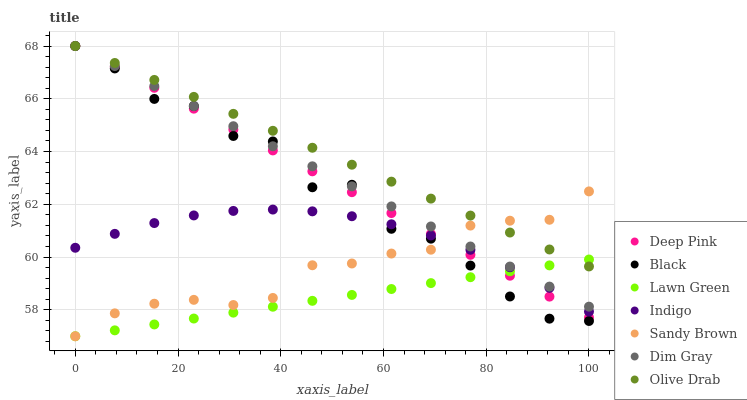Does Lawn Green have the minimum area under the curve?
Answer yes or no. Yes. Does Olive Drab have the maximum area under the curve?
Answer yes or no. Yes. Does Dim Gray have the minimum area under the curve?
Answer yes or no. No. Does Dim Gray have the maximum area under the curve?
Answer yes or no. No. Is Lawn Green the smoothest?
Answer yes or no. Yes. Is Black the roughest?
Answer yes or no. Yes. Is Dim Gray the smoothest?
Answer yes or no. No. Is Dim Gray the roughest?
Answer yes or no. No. Does Lawn Green have the lowest value?
Answer yes or no. Yes. Does Dim Gray have the lowest value?
Answer yes or no. No. Does Olive Drab have the highest value?
Answer yes or no. Yes. Does Indigo have the highest value?
Answer yes or no. No. Is Indigo less than Dim Gray?
Answer yes or no. Yes. Is Dim Gray greater than Indigo?
Answer yes or no. Yes. Does Black intersect Sandy Brown?
Answer yes or no. Yes. Is Black less than Sandy Brown?
Answer yes or no. No. Is Black greater than Sandy Brown?
Answer yes or no. No. Does Indigo intersect Dim Gray?
Answer yes or no. No. 